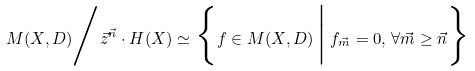<formula> <loc_0><loc_0><loc_500><loc_500>M ( X , D ) \Big / \vec { z } ^ { \vec { n } } \cdot H ( X ) \simeq \Big \{ f \in M ( X , D ) \, \Big | \, f _ { \vec { m } } = 0 , \, \forall \vec { m } \geq \vec { n } \Big \}</formula> 